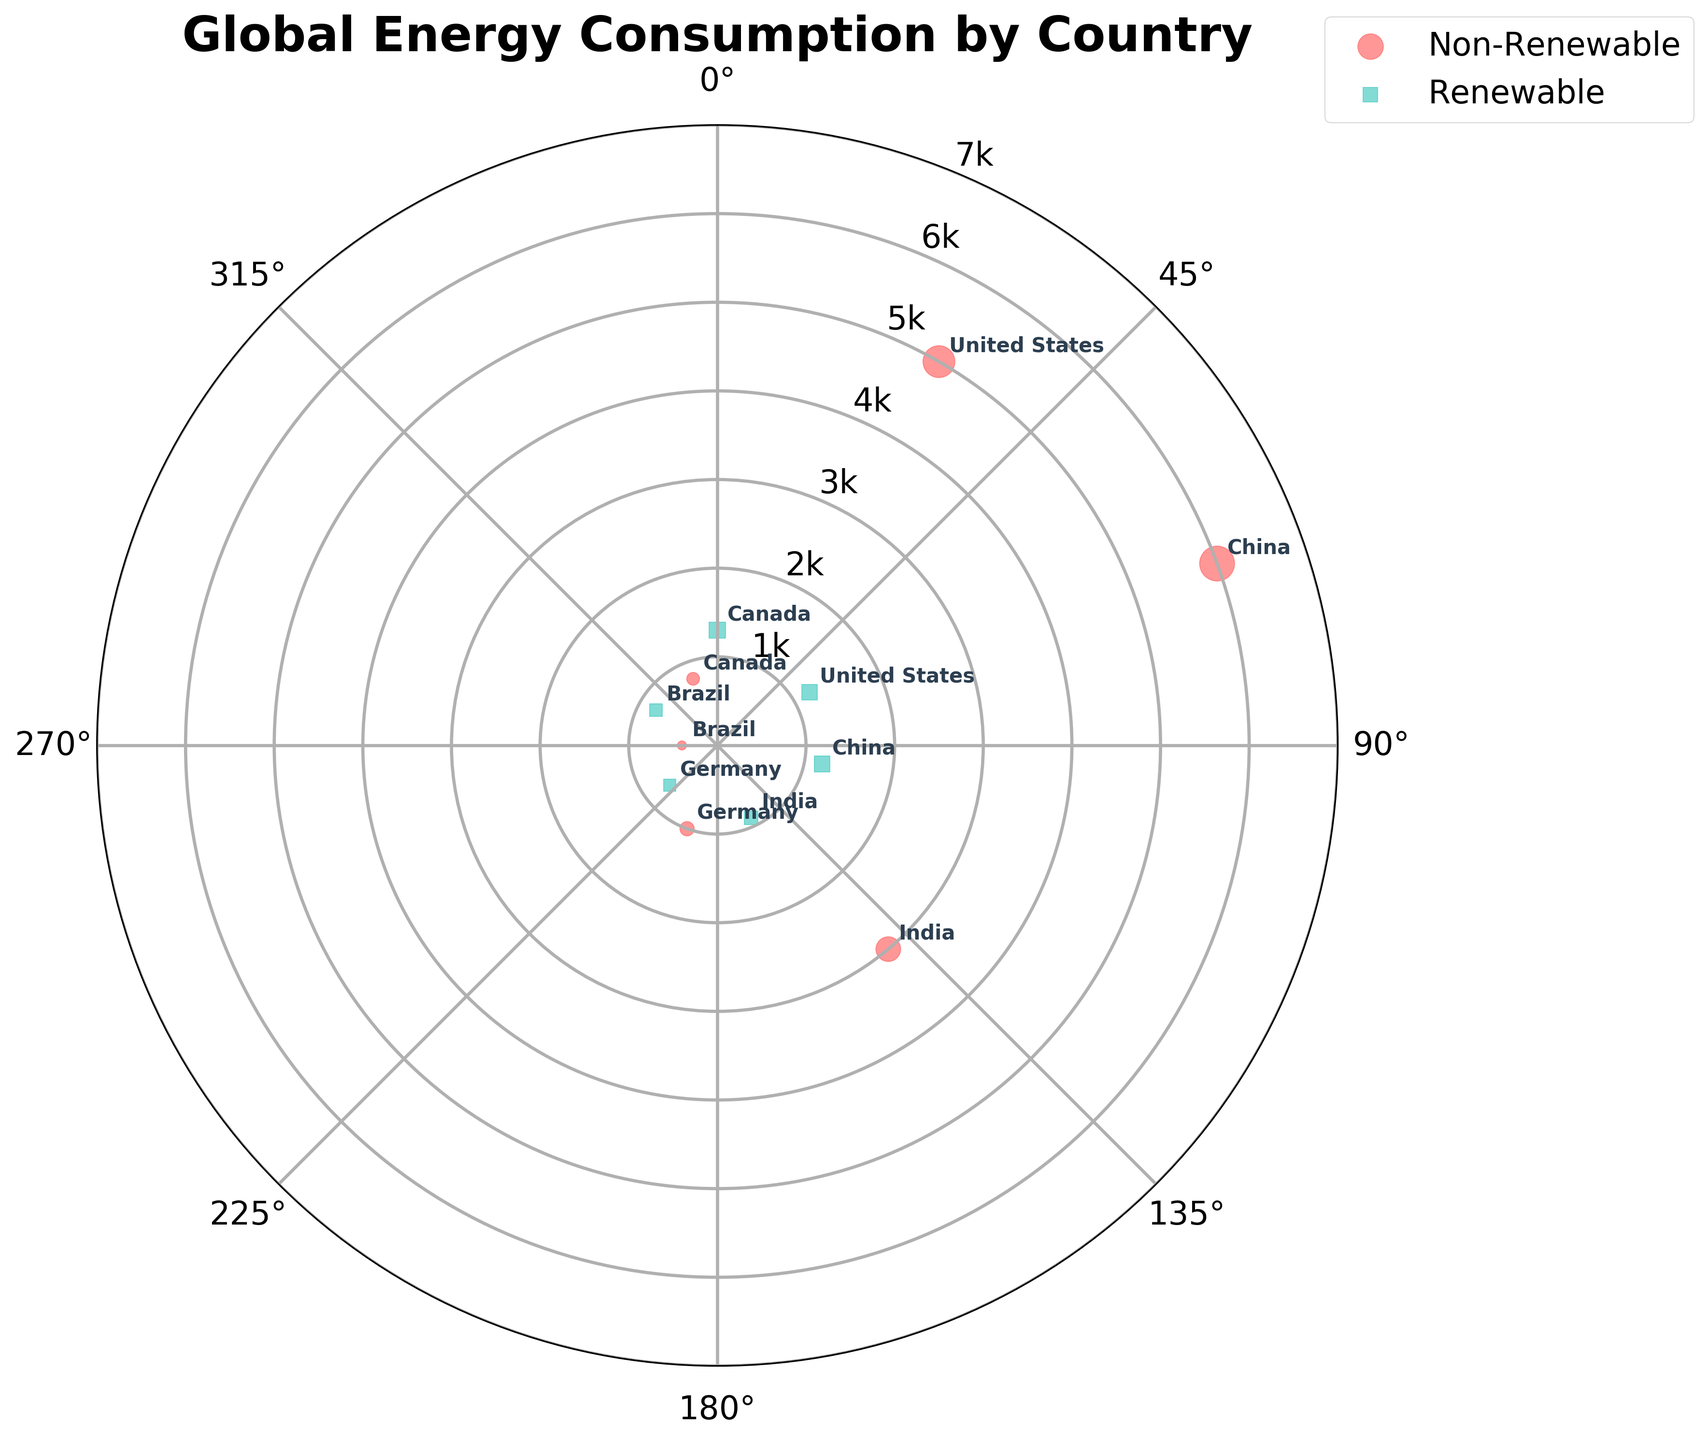What is the title of the plot? The title is typically displayed prominently at the top of the plot. The title of this plot is "Global Energy Consumption by Country".
Answer: Global Energy Consumption by Country How many countries are represented in this plot? Each country is annotated with its name in the plot. By counting the unique country names, we find there are six countries.
Answer: 6 Which country has the largest radius point for Non-Renewable energy? By examining the plot, we see that China has the largest radius point for Non-Renewable energy with a radius of 6000.
Answer: China What are the colors used to distinguish between renewable and non-renewable energy sources? By looking at the legend, we can observe that Non-Renewable energy is marked with a red color, and Renewable energy is marked with a teal color.
Answer: Red for Non-Renewable, Teal for Renewable Which country has the smallest radius point for Non-Renewable energy? By looking at the smallest radius points labeled with a country name, we see that Brazil has the smallest radius point for Non-Renewable energy with a radius of 400.
Answer: Brazil How many renewable energy points have a radius greater than 1000? By examining all renewable energy points and their corresponding radii, we observe that the United States, China, and Canada have renewable points with a radius greater than 1000.
Answer: 3 What is the total radius for renewable energy sources from all countries combined? The radii for renewable energy are 1200 (US) + 1200 (China) + 900 (India) + 700 (Germany) + 800 (Brazil) + 1300 (Canada). Adding these gives the total radius: 1200 + 1200 + 900 + 700 + 800 + 1300 = 6100.
Answer: 6100 What is the difference in radius between China's non-renewable and renewable energy? China's non-renewable radius is 6000, and its renewable radius is 1200. The difference is 6000 - 1200 = 4800.
Answer: 4800 Which country has the most balanced consumption of renewable and non-renewable energy in terms of radius? We can determine the balance by comparing the differences between the radii of renewable and non-renewable energy for each country. The smaller the difference, the more balanced it is. Brazil has a non-renewable radius of 400 and a renewable radius of 800, making the difference 400, which is the smallest among the countries.
Answer: Brazil In which direction (theta) is Canada's renewable energy point located? Canada's renewable energy point is located at 360 degrees, as per its annotation in the figure.
Answer: 360 degrees 